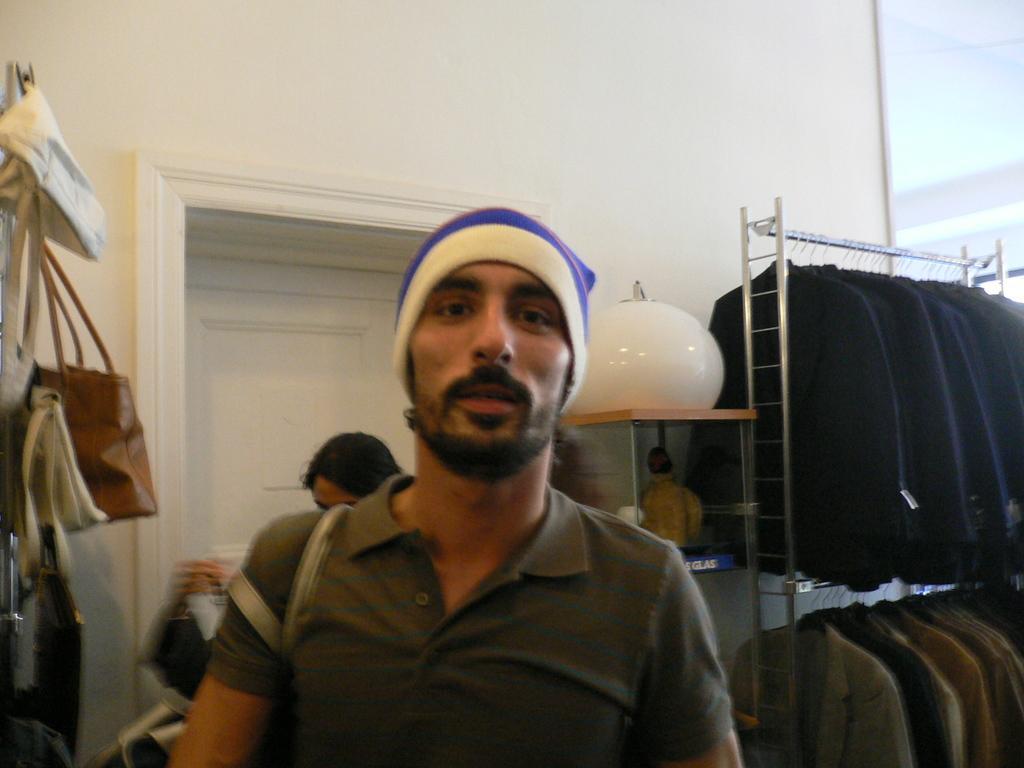Describe this image in one or two sentences. In this picture we can see a person,he is wearing a cap and in the background we can see a woman,bags,wall,clothes are hanged to the hanger. 